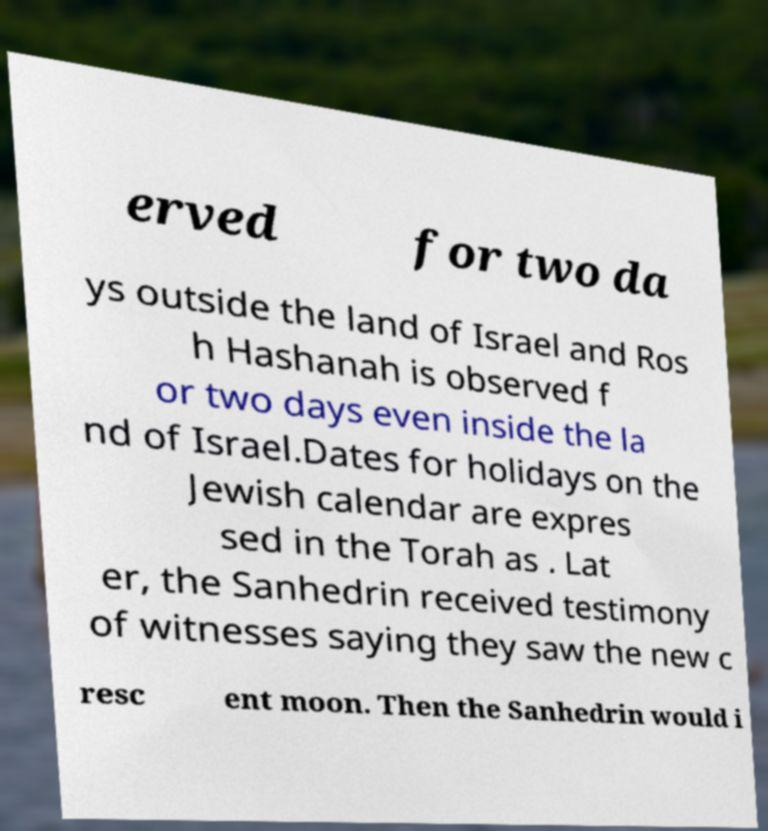For documentation purposes, I need the text within this image transcribed. Could you provide that? erved for two da ys outside the land of Israel and Ros h Hashanah is observed f or two days even inside the la nd of Israel.Dates for holidays on the Jewish calendar are expres sed in the Torah as . Lat er, the Sanhedrin received testimony of witnesses saying they saw the new c resc ent moon. Then the Sanhedrin would i 